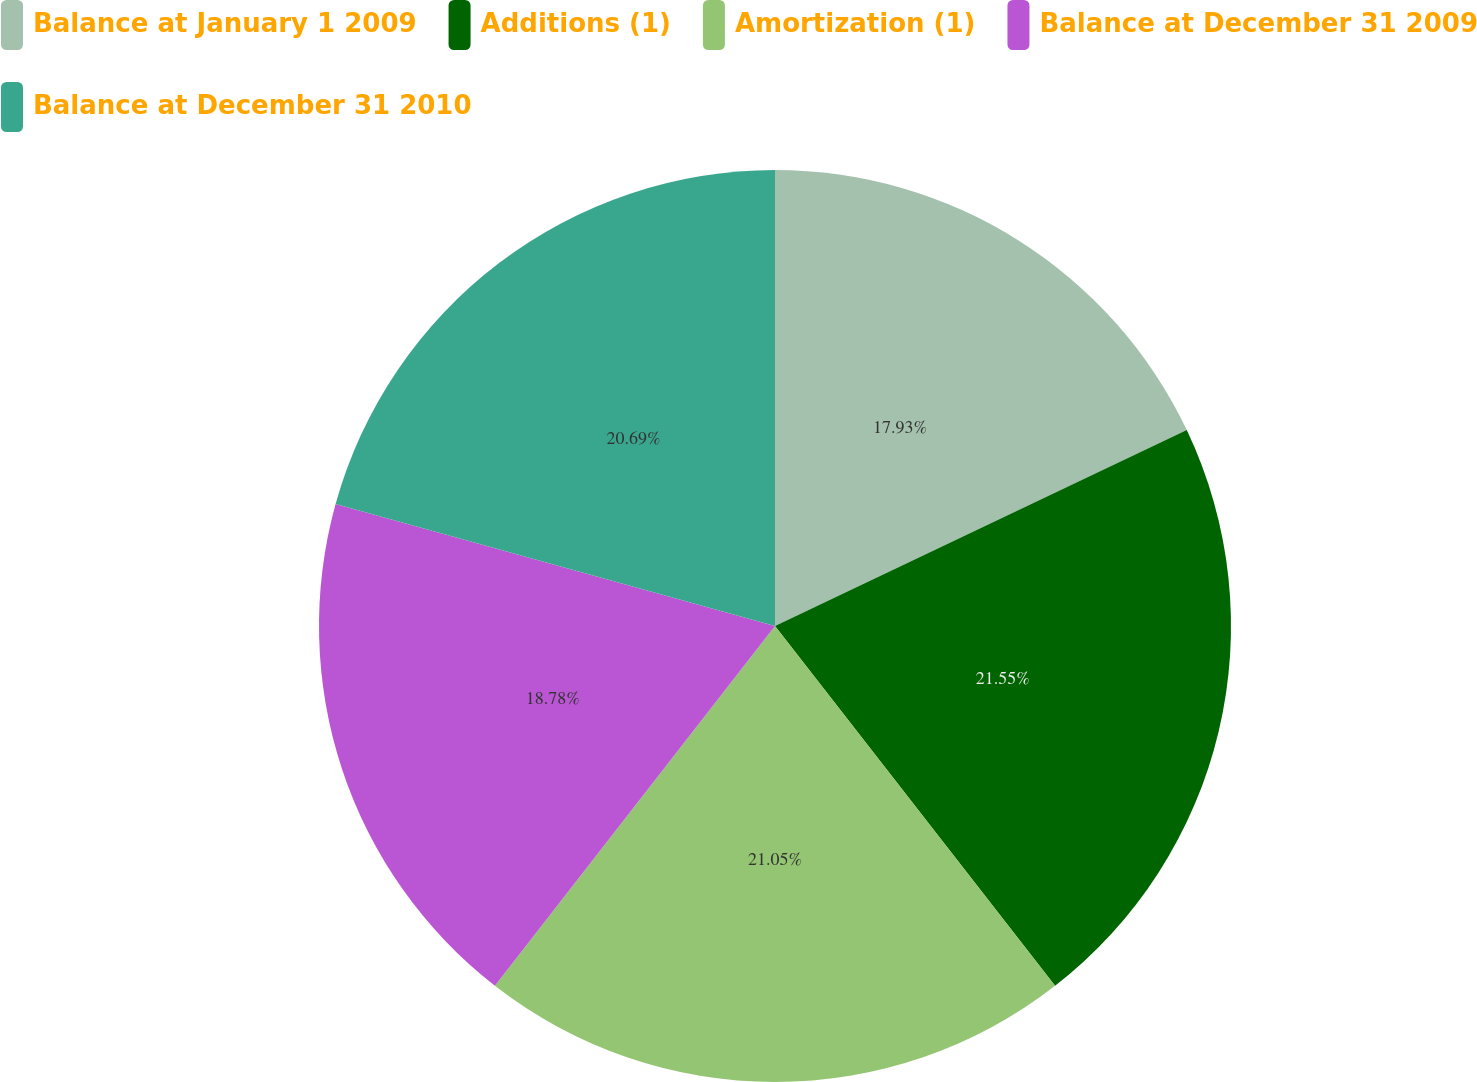<chart> <loc_0><loc_0><loc_500><loc_500><pie_chart><fcel>Balance at January 1 2009<fcel>Additions (1)<fcel>Amortization (1)<fcel>Balance at December 31 2009<fcel>Balance at December 31 2010<nl><fcel>17.93%<fcel>21.54%<fcel>21.05%<fcel>18.78%<fcel>20.69%<nl></chart> 